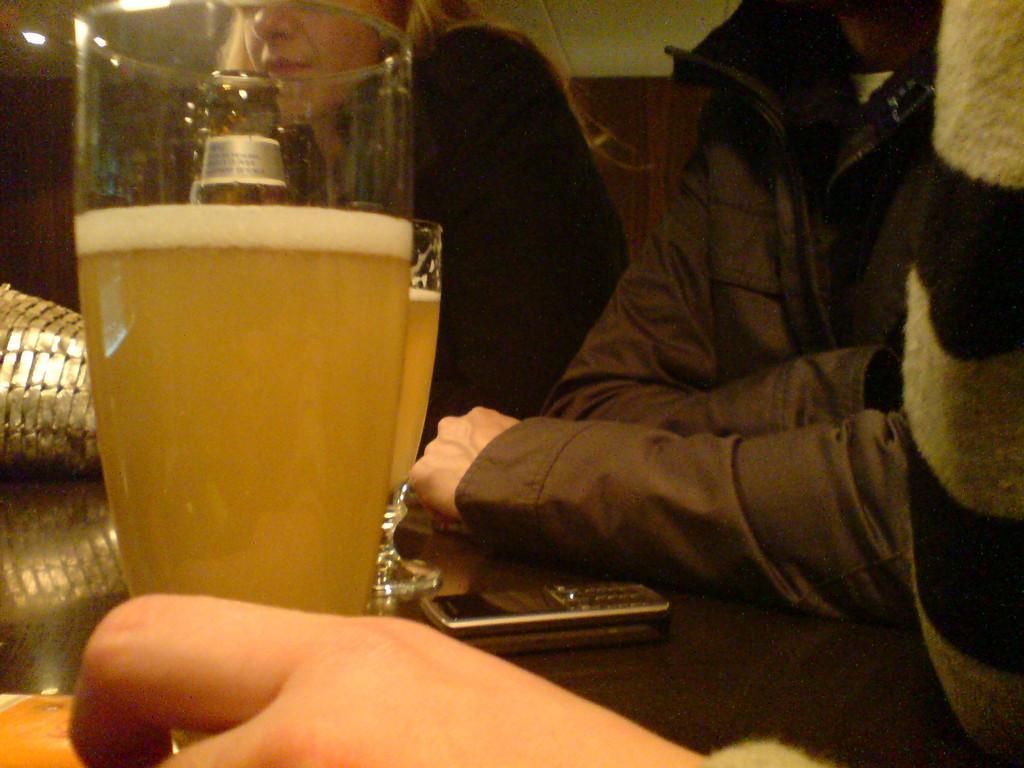Can you describe this image briefly? At the bottom we can see glass with liquid in it and a person hand. On the table we can see a wine bottle,bag,mobile and a glass with liquid in it. In the background we can see two persons,cloth and a wall. 